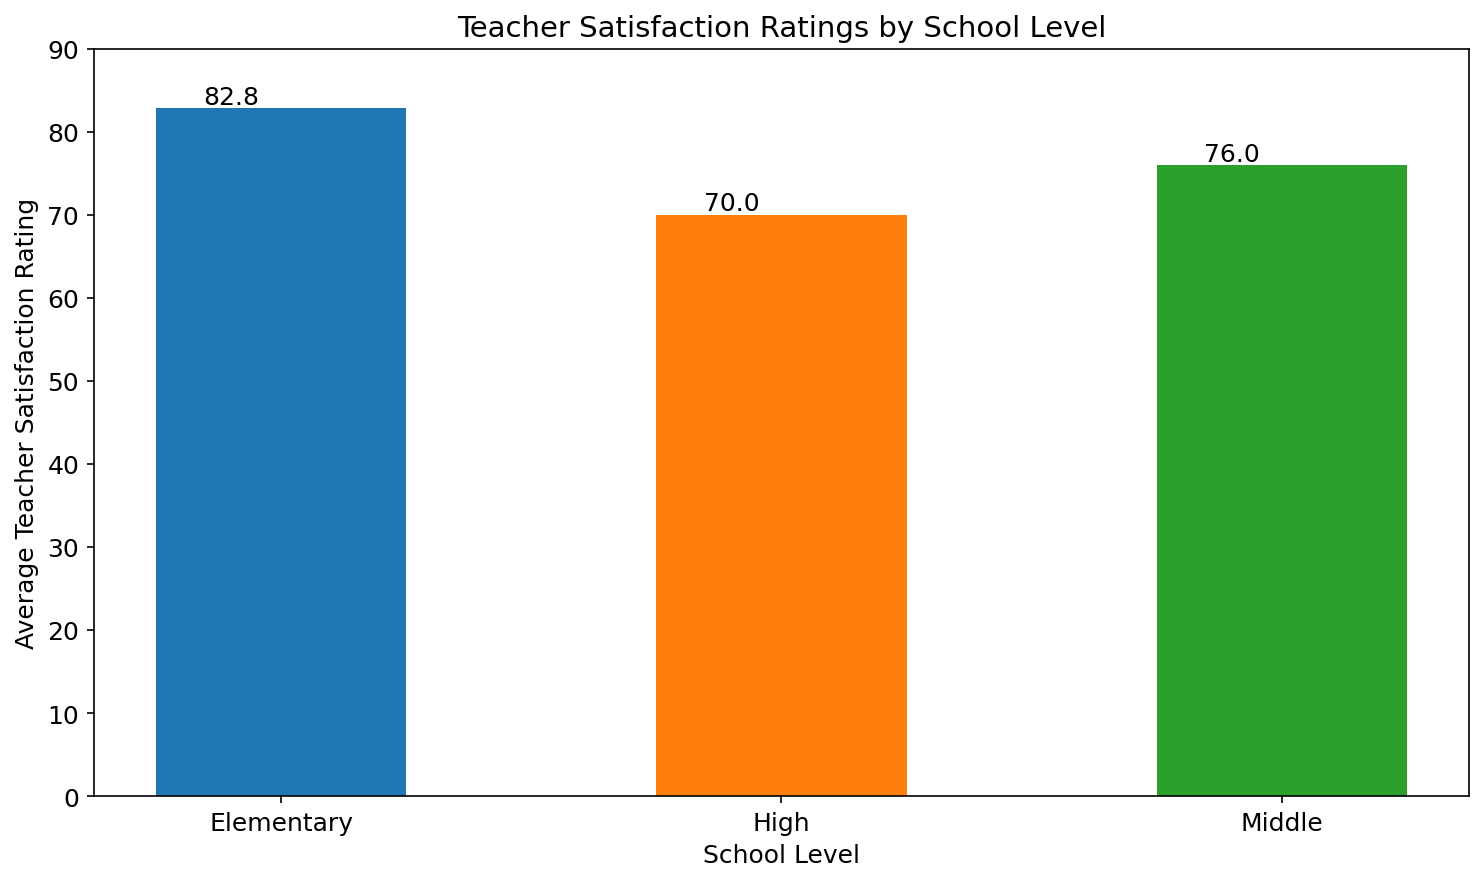What's the average teacher satisfaction rating for Elementary schools? The figure provides the average ratings by school level. The average rating for Elementary schools is given by the heights of the bars. Calculating the mean from the provided data, we find (82 + 84 + 80 + 83 + 85) / 5 = 82.8
Answer: 82.8 Which school level has the lowest average teacher satisfaction rating? By observing the heights of the bars representing each school level, the High school bar is the shortest, indicating the lowest average teacher satisfaction rating
Answer: High What is the difference in average teacher satisfaction ratings between Elementary and Middle schools? The average rating for Elementary schools is 82.8, and for Middle schools it is 76. The difference is calculated as 82.8 - 76 = 6.8
Answer: 6.8 How many school levels have an average teacher satisfaction rating above 75? Observing the heights of the bars, both Elementary (82.8) and Middle (76) have ratings above 75. Hence, there are two school levels with ratings above 75
Answer: 2 What is the total average teacher satisfaction rating, combining all school levels? The average ratings for Elementary, Middle, and High schools are 82.8, 76, and 70 respectively. Sum them up to get the total average: 82.8 + 76 + 70 = 228.8
Answer: 228.8 Which school level shows the highest average teacher satisfaction rating? By examining the heights of the bars, the Elementary school bar is the tallest, indicating the highest average teacher satisfaction rating
Answer: Elementary What is the average teacher satisfaction rating for Middle schools? The figure provides the average ratings by school level. The average rating for Middle schools, given by the height of the specific bar, is calculated as (75 + 78 + 76 + 77 + 74) / 5 = 76
Answer: 76 How much higher is the average teacher satisfaction rating in Elementary schools compared to High schools? The average rating for Elementary schools is 82.8, and for High schools it is 70. The difference is calculated as 82.8 - 70 = 12.8
Answer: 12.8 